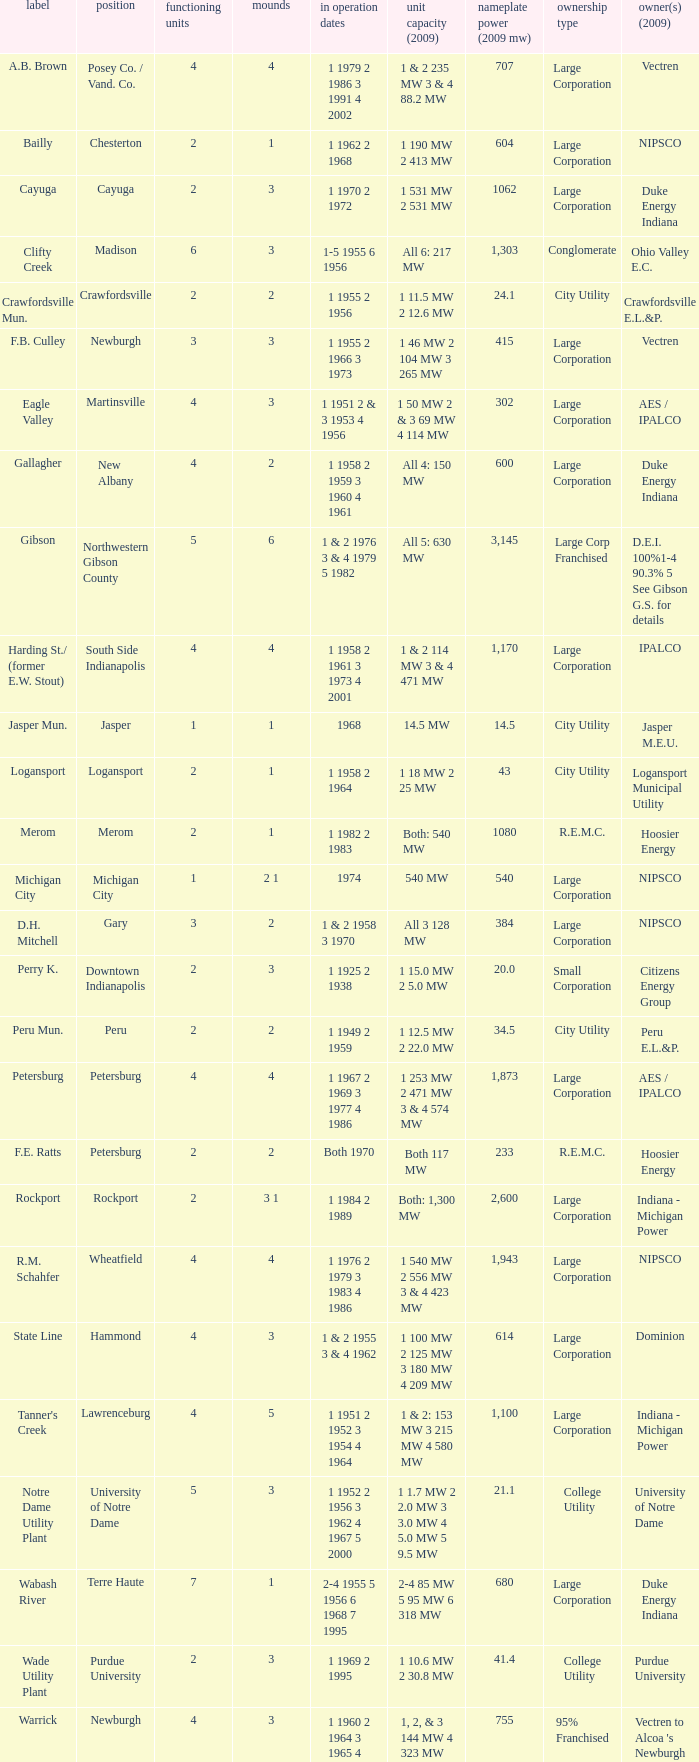Name the number of stacks for 1 & 2 235 mw 3 & 4 88.2 mw 1.0. 